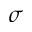<formula> <loc_0><loc_0><loc_500><loc_500>\sigma</formula> 